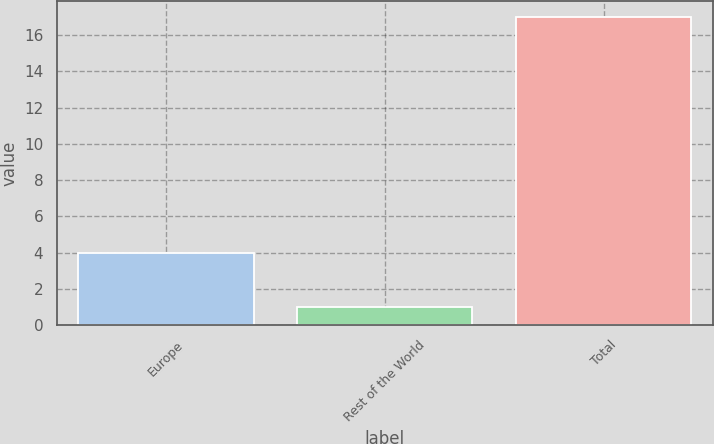Convert chart. <chart><loc_0><loc_0><loc_500><loc_500><bar_chart><fcel>Europe<fcel>Rest of the World<fcel>Total<nl><fcel>4<fcel>1<fcel>17<nl></chart> 